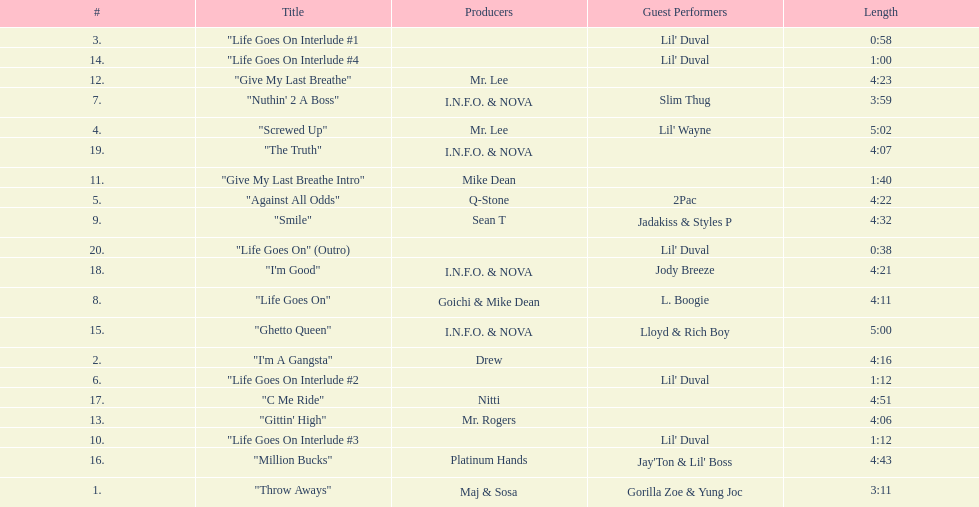What is the first track featuring lil' duval? "Life Goes On Interlude #1. 